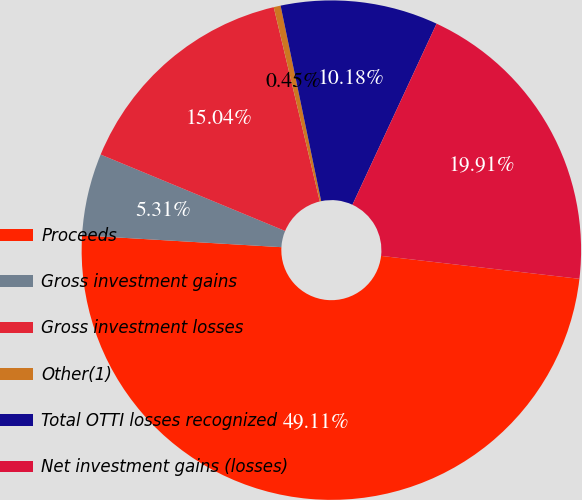Convert chart. <chart><loc_0><loc_0><loc_500><loc_500><pie_chart><fcel>Proceeds<fcel>Gross investment gains<fcel>Gross investment losses<fcel>Other(1)<fcel>Total OTTI losses recognized<fcel>Net investment gains (losses)<nl><fcel>49.11%<fcel>5.31%<fcel>15.04%<fcel>0.45%<fcel>10.18%<fcel>19.91%<nl></chart> 